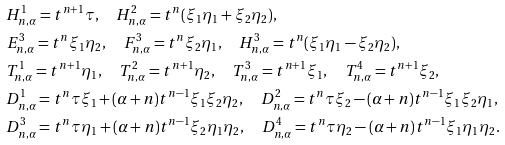Convert formula to latex. <formula><loc_0><loc_0><loc_500><loc_500>& H _ { n , \alpha } ^ { 1 } = t ^ { n + 1 } \tau , \quad H _ { n , \alpha } ^ { 2 } = t ^ { n } ( \xi _ { 1 } \eta _ { 1 } + \xi _ { 2 } \eta _ { 2 } ) , \\ & E _ { n , \alpha } ^ { 3 } = t ^ { n } \xi _ { 1 } \eta _ { 2 } , \quad F _ { n , \alpha } ^ { 3 } = t ^ { n } \xi _ { 2 } \eta _ { 1 } , \quad H _ { n , \alpha } ^ { 3 } = t ^ { n } ( \xi _ { 1 } \eta _ { 1 } - \xi _ { 2 } \eta _ { 2 } ) , \\ & T _ { n , \alpha } ^ { 1 } = t ^ { n + 1 } \eta _ { 1 } , \quad T _ { n , \alpha } ^ { 2 } = t ^ { n + 1 } \eta _ { 2 } , \quad T _ { n , \alpha } ^ { 3 } = t ^ { n + 1 } \xi _ { 1 } , \quad T _ { n , \alpha } ^ { 4 } = t ^ { n + 1 } \xi _ { 2 } , \\ & D _ { n , \alpha } ^ { 1 } = t ^ { n } \tau \xi _ { 1 } + ( \alpha + n ) t ^ { n - 1 } \xi _ { 1 } \xi _ { 2 } \eta _ { 2 } , \quad D _ { n , \alpha } ^ { 2 } = t ^ { n } \tau \xi _ { 2 } - ( \alpha + n ) t ^ { n - 1 } \xi _ { 1 } \xi _ { 2 } \eta _ { 1 } , \\ & D _ { n , \alpha } ^ { 3 } = t ^ { n } \tau \eta _ { 1 } + ( \alpha + n ) t ^ { n - 1 } \xi _ { 2 } \eta _ { 1 } \eta _ { 2 } , \quad D _ { n , \alpha } ^ { 4 } = t ^ { n } \tau \eta _ { 2 } - ( \alpha + n ) t ^ { n - 1 } \xi _ { 1 } \eta _ { 1 } \eta _ { 2 } .</formula> 